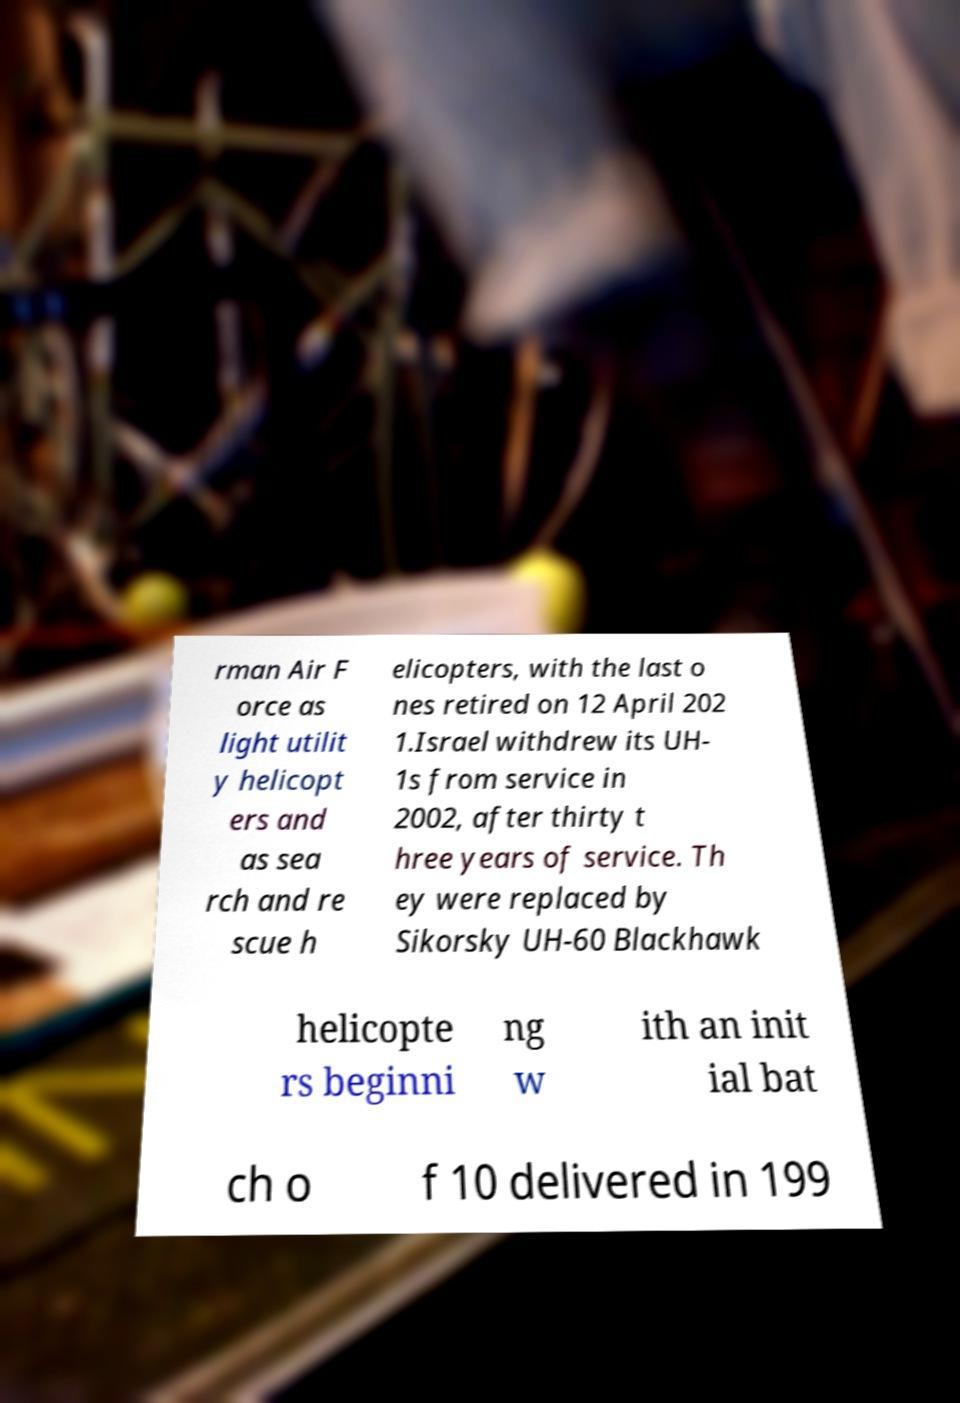Can you read and provide the text displayed in the image?This photo seems to have some interesting text. Can you extract and type it out for me? rman Air F orce as light utilit y helicopt ers and as sea rch and re scue h elicopters, with the last o nes retired on 12 April 202 1.Israel withdrew its UH- 1s from service in 2002, after thirty t hree years of service. Th ey were replaced by Sikorsky UH-60 Blackhawk helicopte rs beginni ng w ith an init ial bat ch o f 10 delivered in 199 